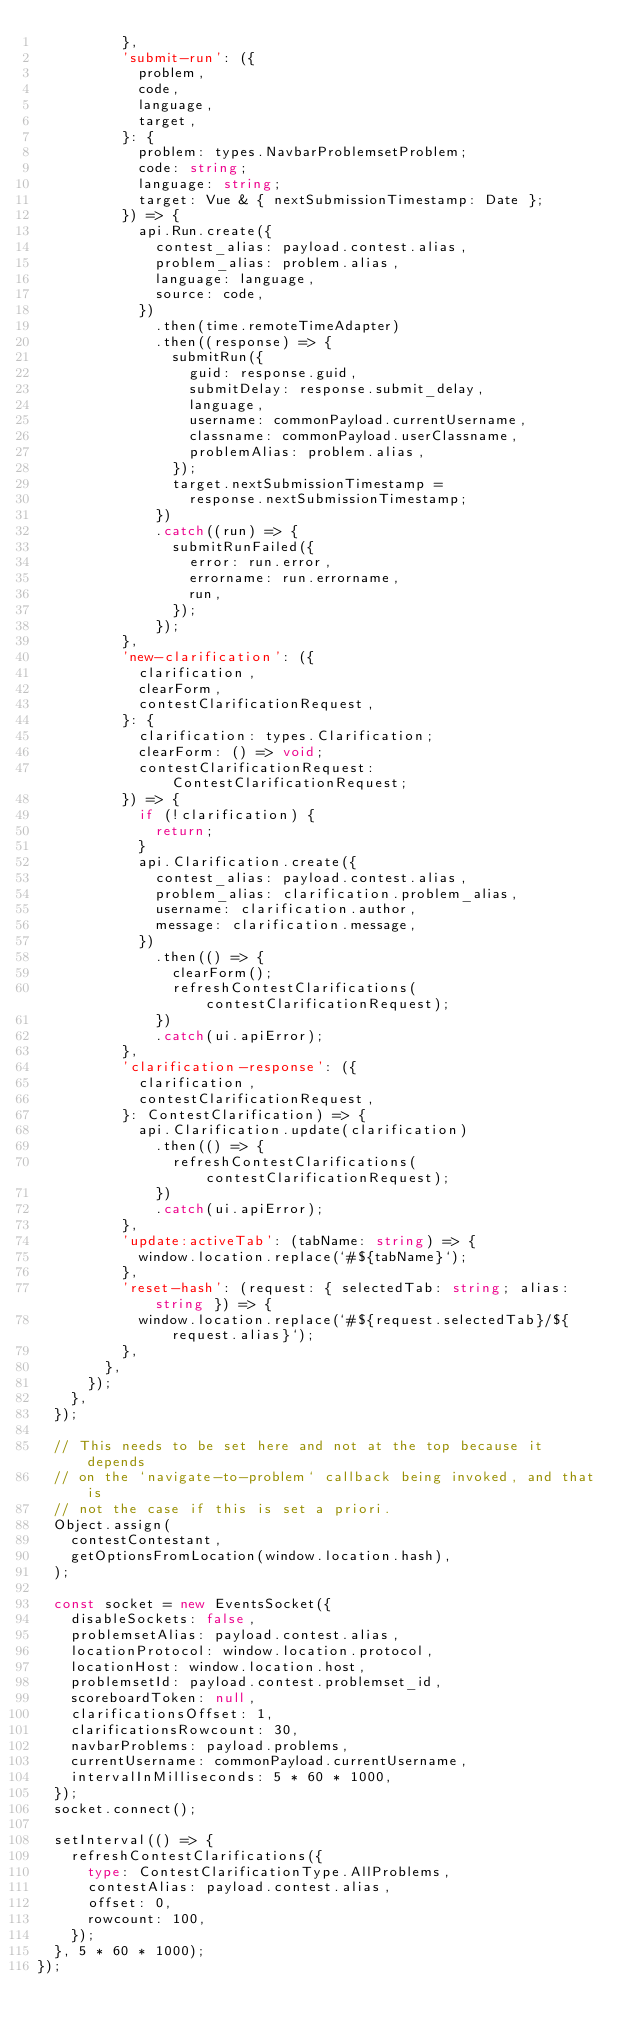Convert code to text. <code><loc_0><loc_0><loc_500><loc_500><_TypeScript_>          },
          'submit-run': ({
            problem,
            code,
            language,
            target,
          }: {
            problem: types.NavbarProblemsetProblem;
            code: string;
            language: string;
            target: Vue & { nextSubmissionTimestamp: Date };
          }) => {
            api.Run.create({
              contest_alias: payload.contest.alias,
              problem_alias: problem.alias,
              language: language,
              source: code,
            })
              .then(time.remoteTimeAdapter)
              .then((response) => {
                submitRun({
                  guid: response.guid,
                  submitDelay: response.submit_delay,
                  language,
                  username: commonPayload.currentUsername,
                  classname: commonPayload.userClassname,
                  problemAlias: problem.alias,
                });
                target.nextSubmissionTimestamp =
                  response.nextSubmissionTimestamp;
              })
              .catch((run) => {
                submitRunFailed({
                  error: run.error,
                  errorname: run.errorname,
                  run,
                });
              });
          },
          'new-clarification': ({
            clarification,
            clearForm,
            contestClarificationRequest,
          }: {
            clarification: types.Clarification;
            clearForm: () => void;
            contestClarificationRequest: ContestClarificationRequest;
          }) => {
            if (!clarification) {
              return;
            }
            api.Clarification.create({
              contest_alias: payload.contest.alias,
              problem_alias: clarification.problem_alias,
              username: clarification.author,
              message: clarification.message,
            })
              .then(() => {
                clearForm();
                refreshContestClarifications(contestClarificationRequest);
              })
              .catch(ui.apiError);
          },
          'clarification-response': ({
            clarification,
            contestClarificationRequest,
          }: ContestClarification) => {
            api.Clarification.update(clarification)
              .then(() => {
                refreshContestClarifications(contestClarificationRequest);
              })
              .catch(ui.apiError);
          },
          'update:activeTab': (tabName: string) => {
            window.location.replace(`#${tabName}`);
          },
          'reset-hash': (request: { selectedTab: string; alias: string }) => {
            window.location.replace(`#${request.selectedTab}/${request.alias}`);
          },
        },
      });
    },
  });

  // This needs to be set here and not at the top because it depends
  // on the `navigate-to-problem` callback being invoked, and that is
  // not the case if this is set a priori.
  Object.assign(
    contestContestant,
    getOptionsFromLocation(window.location.hash),
  );

  const socket = new EventsSocket({
    disableSockets: false,
    problemsetAlias: payload.contest.alias,
    locationProtocol: window.location.protocol,
    locationHost: window.location.host,
    problemsetId: payload.contest.problemset_id,
    scoreboardToken: null,
    clarificationsOffset: 1,
    clarificationsRowcount: 30,
    navbarProblems: payload.problems,
    currentUsername: commonPayload.currentUsername,
    intervalInMilliseconds: 5 * 60 * 1000,
  });
  socket.connect();

  setInterval(() => {
    refreshContestClarifications({
      type: ContestClarificationType.AllProblems,
      contestAlias: payload.contest.alias,
      offset: 0,
      rowcount: 100,
    });
  }, 5 * 60 * 1000);
});
</code> 